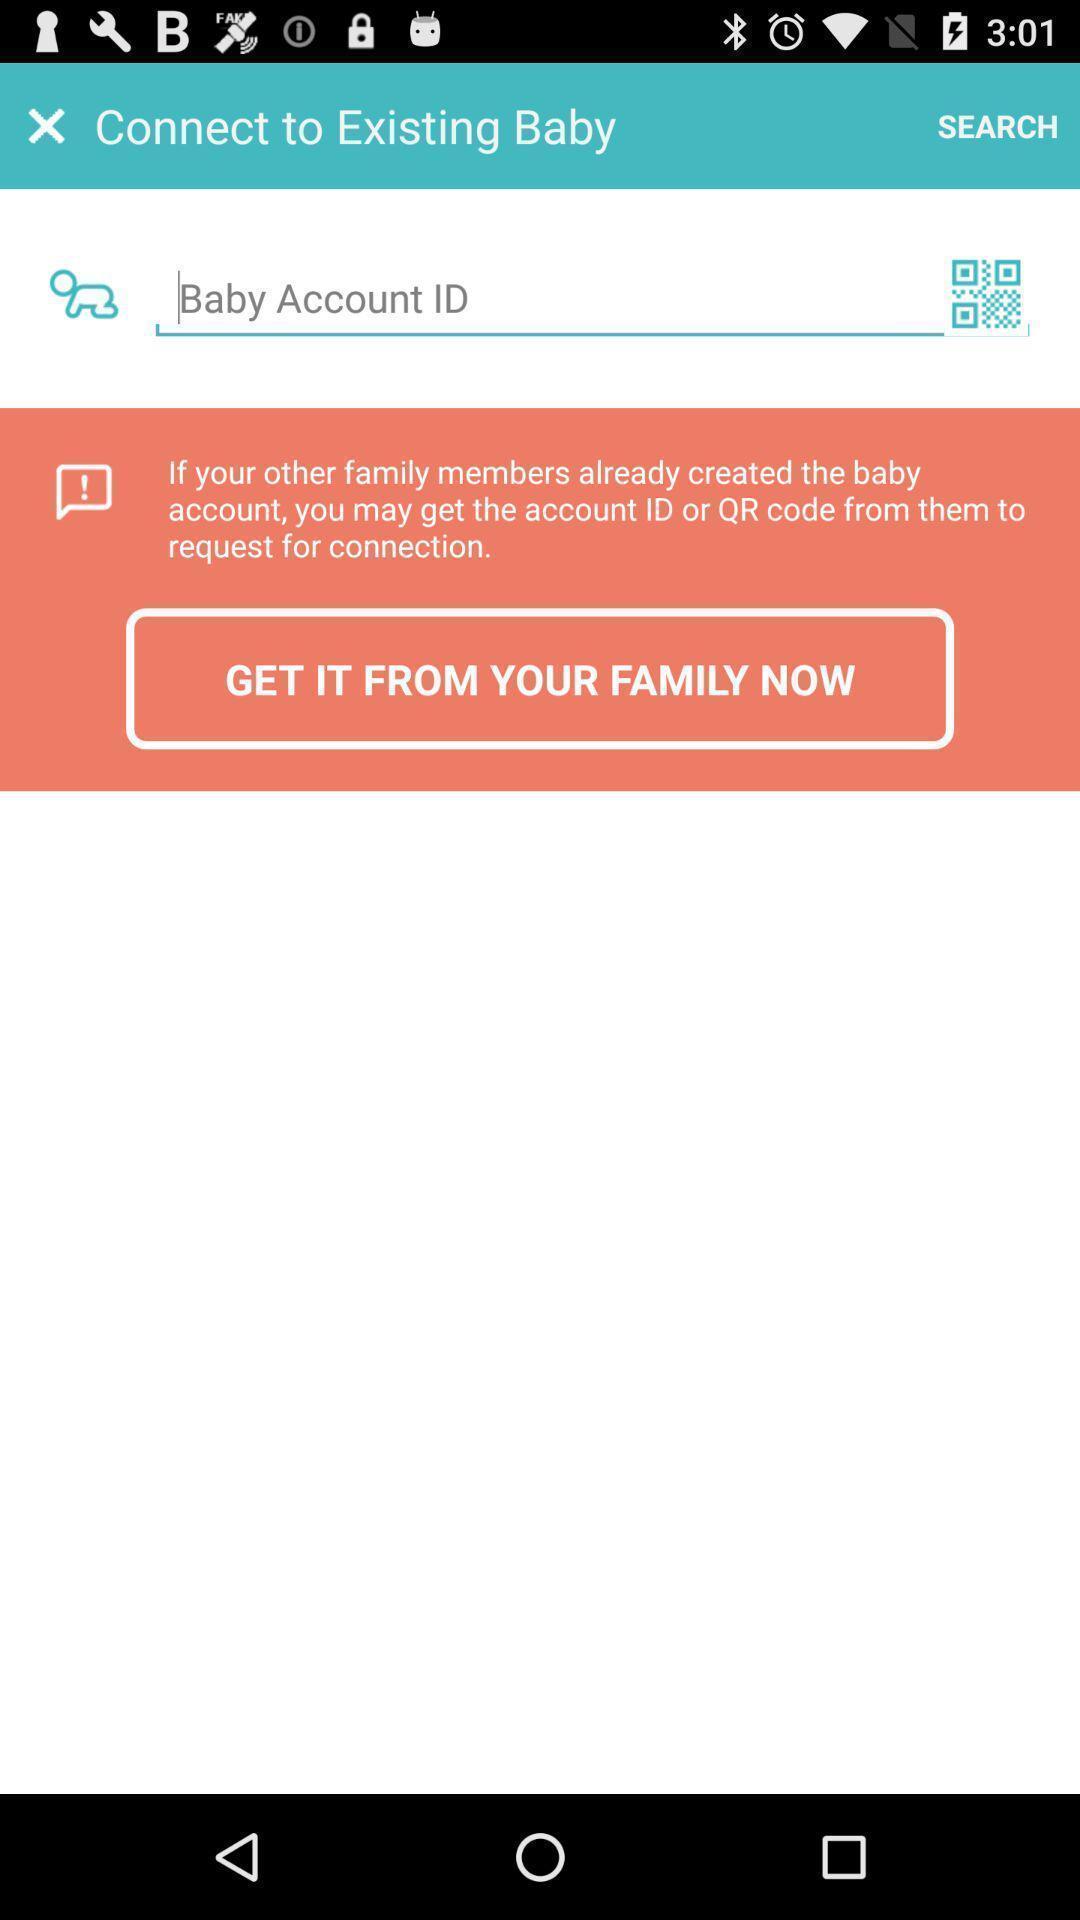What can you discern from this picture? Screen showing to enter account id option. 